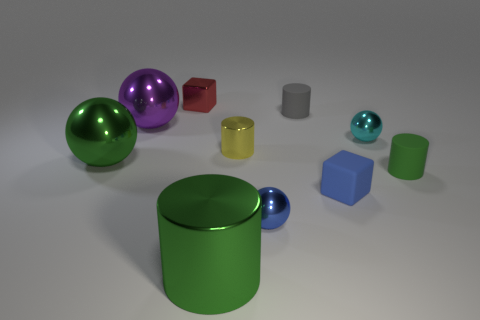Subtract all cyan balls. How many balls are left? 3 Subtract all cyan cubes. How many green cylinders are left? 2 Subtract all blue cubes. How many cubes are left? 1 Subtract all cubes. How many objects are left? 8 Subtract all cyan cylinders. Subtract all gray cubes. How many cylinders are left? 4 Subtract all brown shiny blocks. Subtract all big green objects. How many objects are left? 8 Add 4 tiny blue cubes. How many tiny blue cubes are left? 5 Add 4 tiny purple cylinders. How many tiny purple cylinders exist? 4 Subtract 0 gray blocks. How many objects are left? 10 Subtract 2 spheres. How many spheres are left? 2 